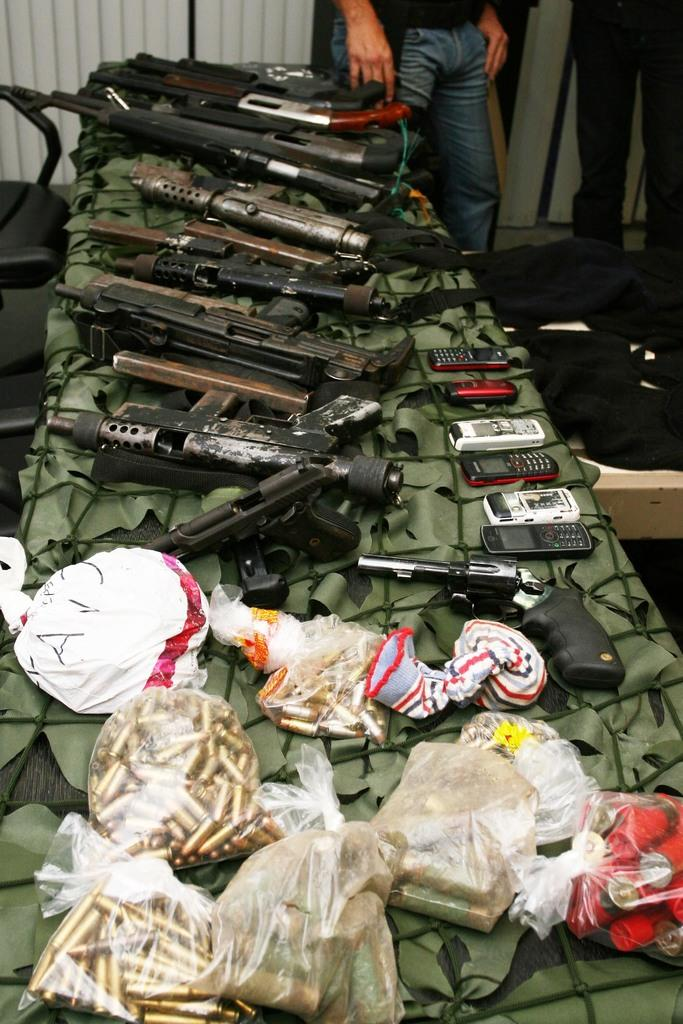What type of weapons are present in the image? There are guns in the image. What other objects can be seen in the image? There are mobiles and bullets in the image. What is the arrangement of these objects? The objects are on a platform in the image. What can be seen in the background of the image? There is a chair, a curtain, and person's legs visible in the background of the image. What type of material is present in the background? There is cloth in the background of the image. What type of cloud can be seen in the image? There is no cloud present in the image. What attraction is visible in the image? There is no attraction present in the image. 